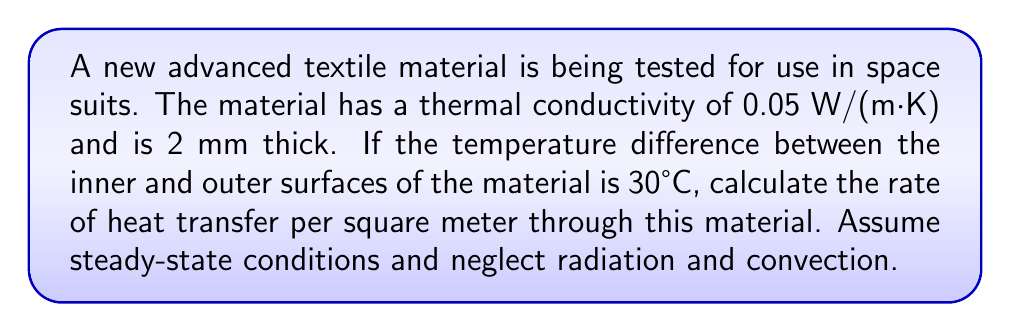Show me your answer to this math problem. To solve this problem, we'll use Fourier's law of heat conduction, which describes the rate of heat transfer through a material. The equation is:

$$q = -k \frac{dT}{dx}$$

Where:
$q$ = heat flux (W/m²)
$k$ = thermal conductivity of the material (W/(m·K))
$\frac{dT}{dx}$ = temperature gradient (K/m)

For a flat slab of material with constant thermal conductivity and steady-state conditions, we can simplify this to:

$$q = k \frac{\Delta T}{L}$$

Where:
$\Delta T$ = temperature difference between the two surfaces (K or °C)
$L$ = thickness of the material (m)

Given:
$k = 0.05$ W/(m·K)
$L = 2$ mm $= 0.002$ m
$\Delta T = 30°C = 30$ K (temperature difference is the same in °C and K)

Substituting these values into the equation:

$$q = 0.05 \frac{\text{W}}{\text{m}\cdot\text{K}} \cdot \frac{30\text{ K}}{0.002\text{ m}}$$

$$q = 0.05 \cdot \frac{30}{0.002} \text{ W/m²}$$

$$q = 750 \text{ W/m²}$$

This result represents the rate of heat transfer per square meter through the advanced textile material.
Answer: 750 W/m² 